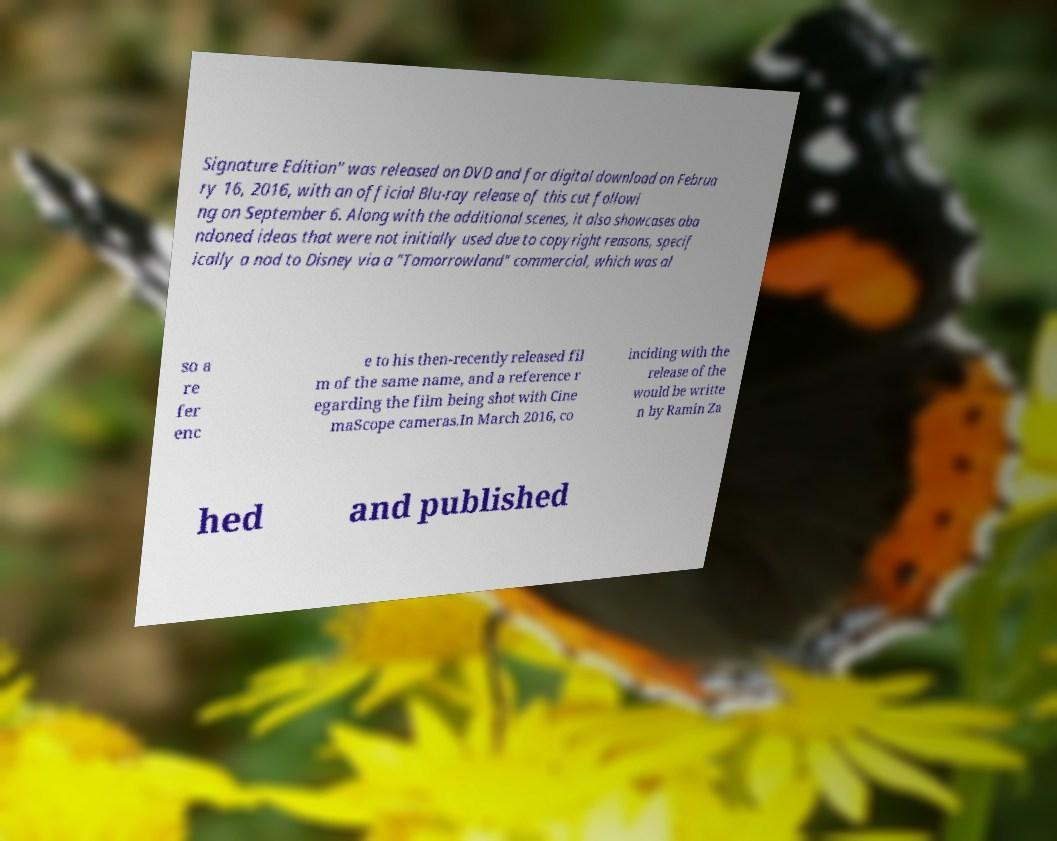For documentation purposes, I need the text within this image transcribed. Could you provide that? Signature Edition" was released on DVD and for digital download on Februa ry 16, 2016, with an official Blu-ray release of this cut followi ng on September 6. Along with the additional scenes, it also showcases aba ndoned ideas that were not initially used due to copyright reasons, specif ically a nod to Disney via a "Tomorrowland" commercial, which was al so a re fer enc e to his then-recently released fil m of the same name, and a reference r egarding the film being shot with Cine maScope cameras.In March 2016, co inciding with the release of the would be writte n by Ramin Za hed and published 